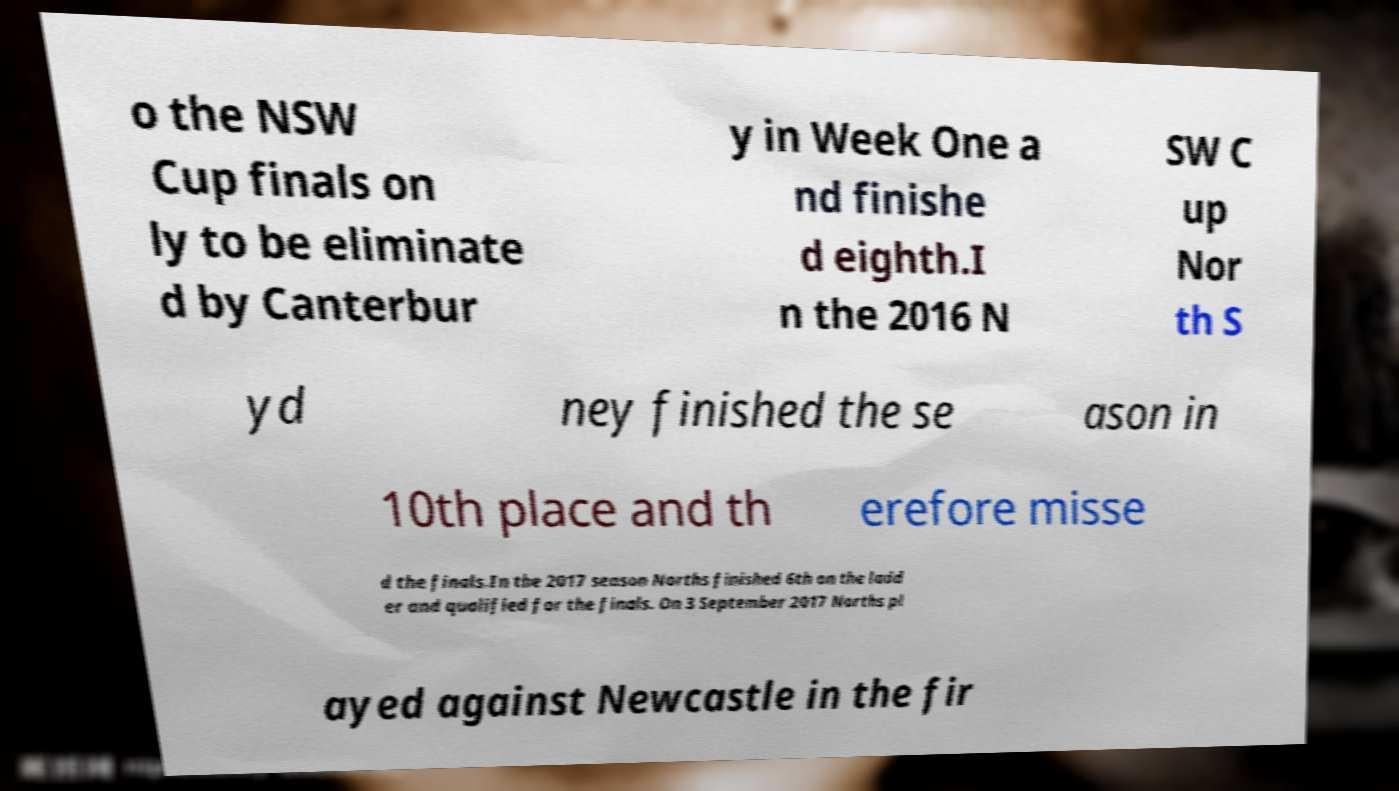Please identify and transcribe the text found in this image. o the NSW Cup finals on ly to be eliminate d by Canterbur y in Week One a nd finishe d eighth.I n the 2016 N SW C up Nor th S yd ney finished the se ason in 10th place and th erefore misse d the finals.In the 2017 season Norths finished 6th on the ladd er and qualified for the finals. On 3 September 2017 Norths pl ayed against Newcastle in the fir 